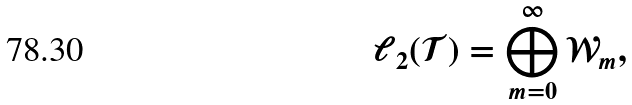<formula> <loc_0><loc_0><loc_500><loc_500>\ell _ { 2 } ( \mathcal { T } ) = \bigoplus _ { m = 0 } ^ { \infty } { \mathcal { W } } _ { m } ,</formula> 